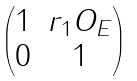<formula> <loc_0><loc_0><loc_500><loc_500>\begin{pmatrix} 1 & r _ { 1 } O _ { E } \\ 0 & 1 \end{pmatrix}</formula> 